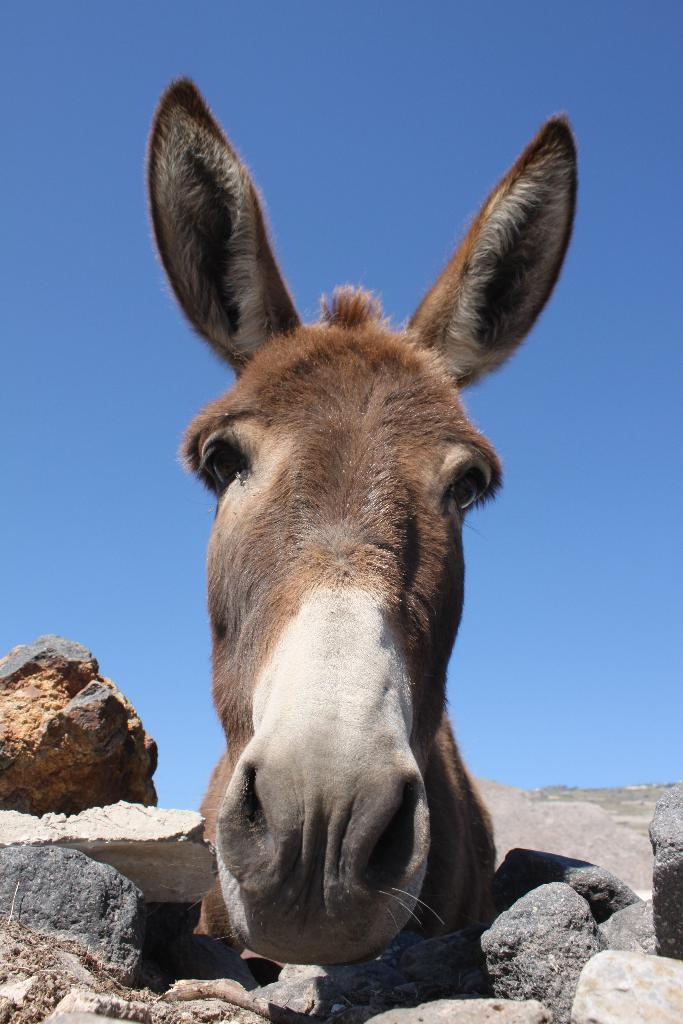What animal's face can be seen in the image? There is a donkey's face visible in the image. Where is the donkey's face located in relation to other objects in the image? The donkey's face is between rocks. What color is the sky in the background of the image? The sky is blue in the background of the image. What type of skin care products are visible in the image? There are no skin care products visible in the image; it features a donkey's face between rocks with a blue sky in the background. 